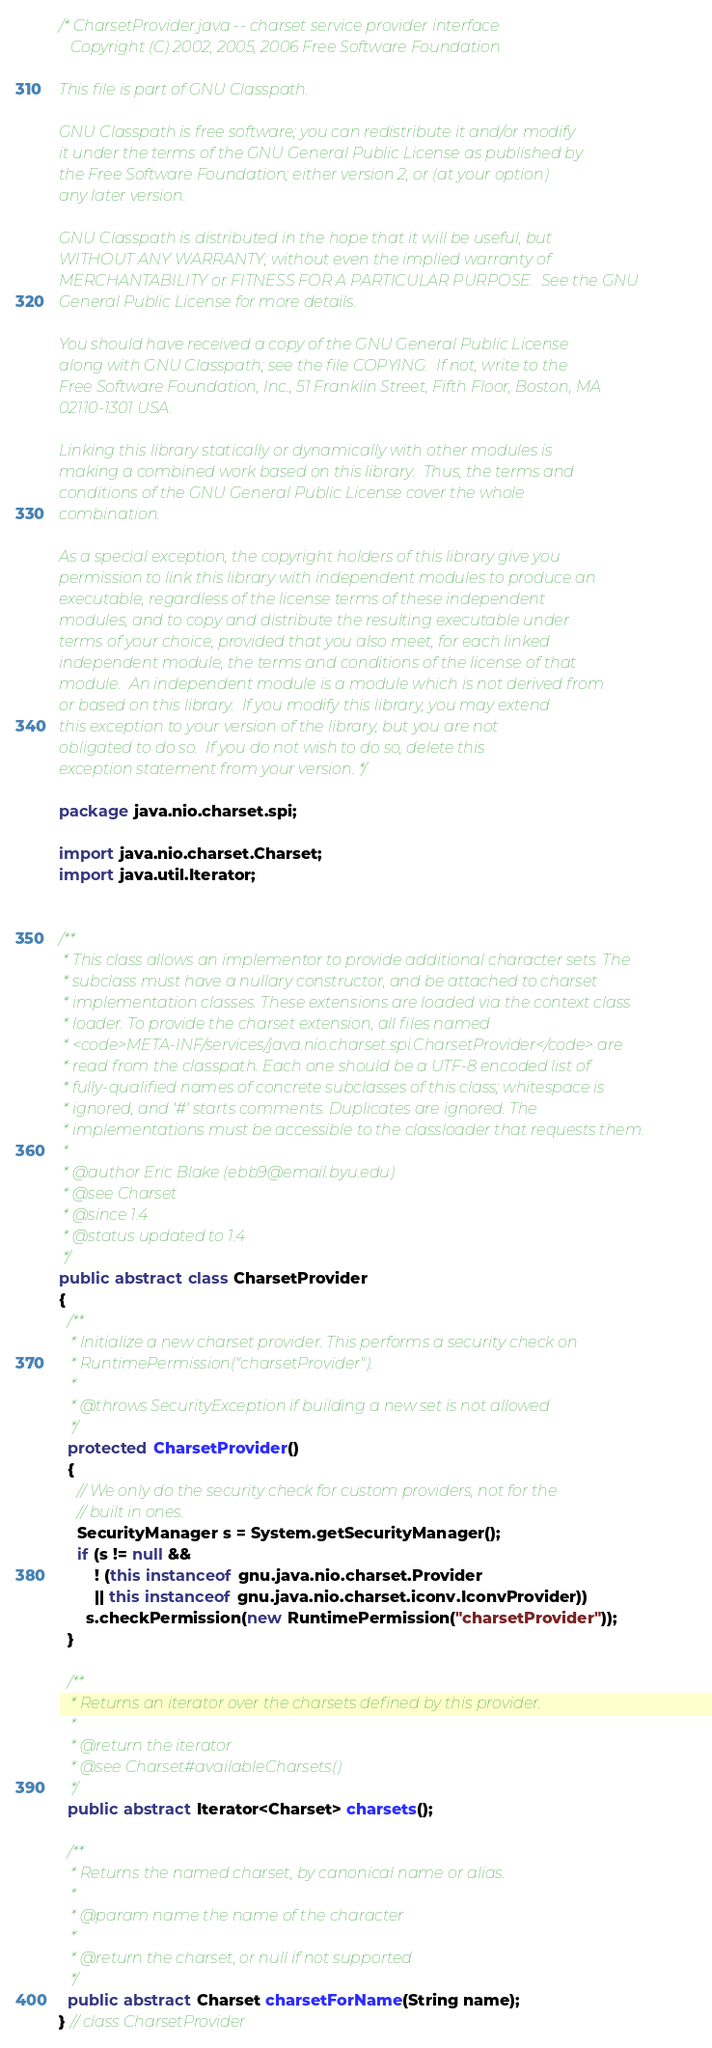Convert code to text. <code><loc_0><loc_0><loc_500><loc_500><_Java_>/* CharsetProvider.java -- charset service provider interface
   Copyright (C) 2002, 2005, 2006 Free Software Foundation

This file is part of GNU Classpath.

GNU Classpath is free software; you can redistribute it and/or modify
it under the terms of the GNU General Public License as published by
the Free Software Foundation; either version 2, or (at your option)
any later version.

GNU Classpath is distributed in the hope that it will be useful, but
WITHOUT ANY WARRANTY; without even the implied warranty of
MERCHANTABILITY or FITNESS FOR A PARTICULAR PURPOSE.  See the GNU
General Public License for more details.

You should have received a copy of the GNU General Public License
along with GNU Classpath; see the file COPYING.  If not, write to the
Free Software Foundation, Inc., 51 Franklin Street, Fifth Floor, Boston, MA
02110-1301 USA.

Linking this library statically or dynamically with other modules is
making a combined work based on this library.  Thus, the terms and
conditions of the GNU General Public License cover the whole
combination.

As a special exception, the copyright holders of this library give you
permission to link this library with independent modules to produce an
executable, regardless of the license terms of these independent
modules, and to copy and distribute the resulting executable under
terms of your choice, provided that you also meet, for each linked
independent module, the terms and conditions of the license of that
module.  An independent module is a module which is not derived from
or based on this library.  If you modify this library, you may extend
this exception to your version of the library, but you are not
obligated to do so.  If you do not wish to do so, delete this
exception statement from your version. */

package java.nio.charset.spi;

import java.nio.charset.Charset;
import java.util.Iterator;


/**
 * This class allows an implementor to provide additional character sets. The
 * subclass must have a nullary constructor, and be attached to charset
 * implementation classes. These extensions are loaded via the context class
 * loader. To provide the charset extension, all files named
 * <code>META-INF/services/java.nio.charset.spi.CharsetProvider</code> are
 * read from the classpath. Each one should be a UTF-8 encoded list of
 * fully-qualified names of concrete subclasses of this class; whitespace is
 * ignored, and '#' starts comments. Duplicates are ignored. The
 * implementations must be accessible to the classloader that requests them.
 *
 * @author Eric Blake (ebb9@email.byu.edu)
 * @see Charset
 * @since 1.4
 * @status updated to 1.4
 */
public abstract class CharsetProvider
{
  /**
   * Initialize a new charset provider. This performs a security check on
   * RuntimePermission("charsetProvider").
   *
   * @throws SecurityException if building a new set is not allowed
   */
  protected CharsetProvider()
  {
    // We only do the security check for custom providers, not for the
    // built in ones.
    SecurityManager s = System.getSecurityManager();
    if (s != null &&
        ! (this instanceof gnu.java.nio.charset.Provider
        || this instanceof gnu.java.nio.charset.iconv.IconvProvider))
      s.checkPermission(new RuntimePermission("charsetProvider"));
  }

  /**
   * Returns an iterator over the charsets defined by this provider.
   *
   * @return the iterator
   * @see Charset#availableCharsets()
   */
  public abstract Iterator<Charset> charsets();

  /**
   * Returns the named charset, by canonical name or alias.
   *
   * @param name the name of the character
   *
   * @return the charset, or null if not supported
   */
  public abstract Charset charsetForName(String name);
} // class CharsetProvider
</code> 